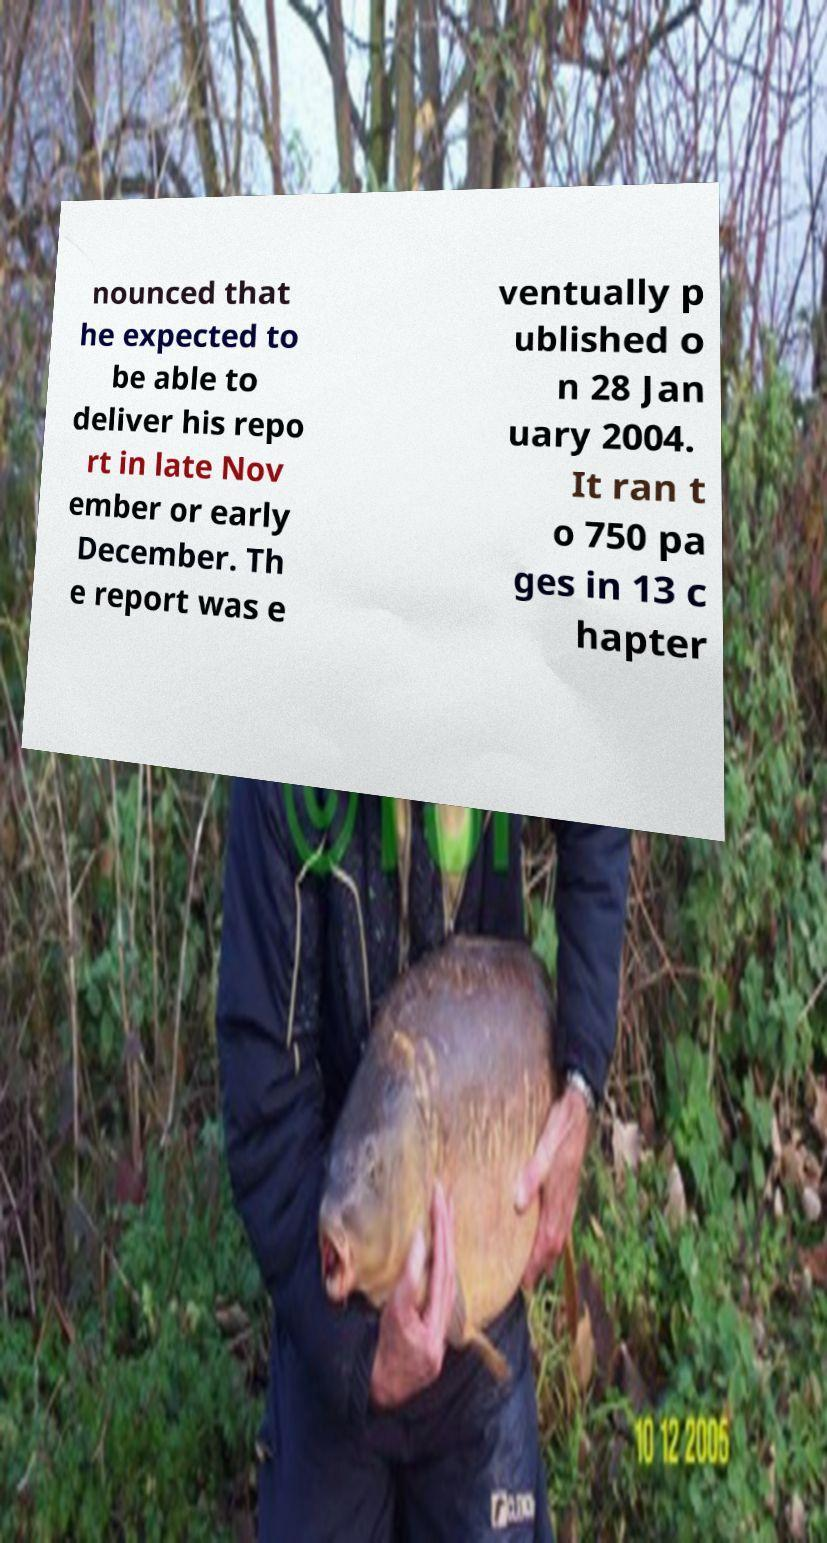There's text embedded in this image that I need extracted. Can you transcribe it verbatim? nounced that he expected to be able to deliver his repo rt in late Nov ember or early December. Th e report was e ventually p ublished o n 28 Jan uary 2004. It ran t o 750 pa ges in 13 c hapter 